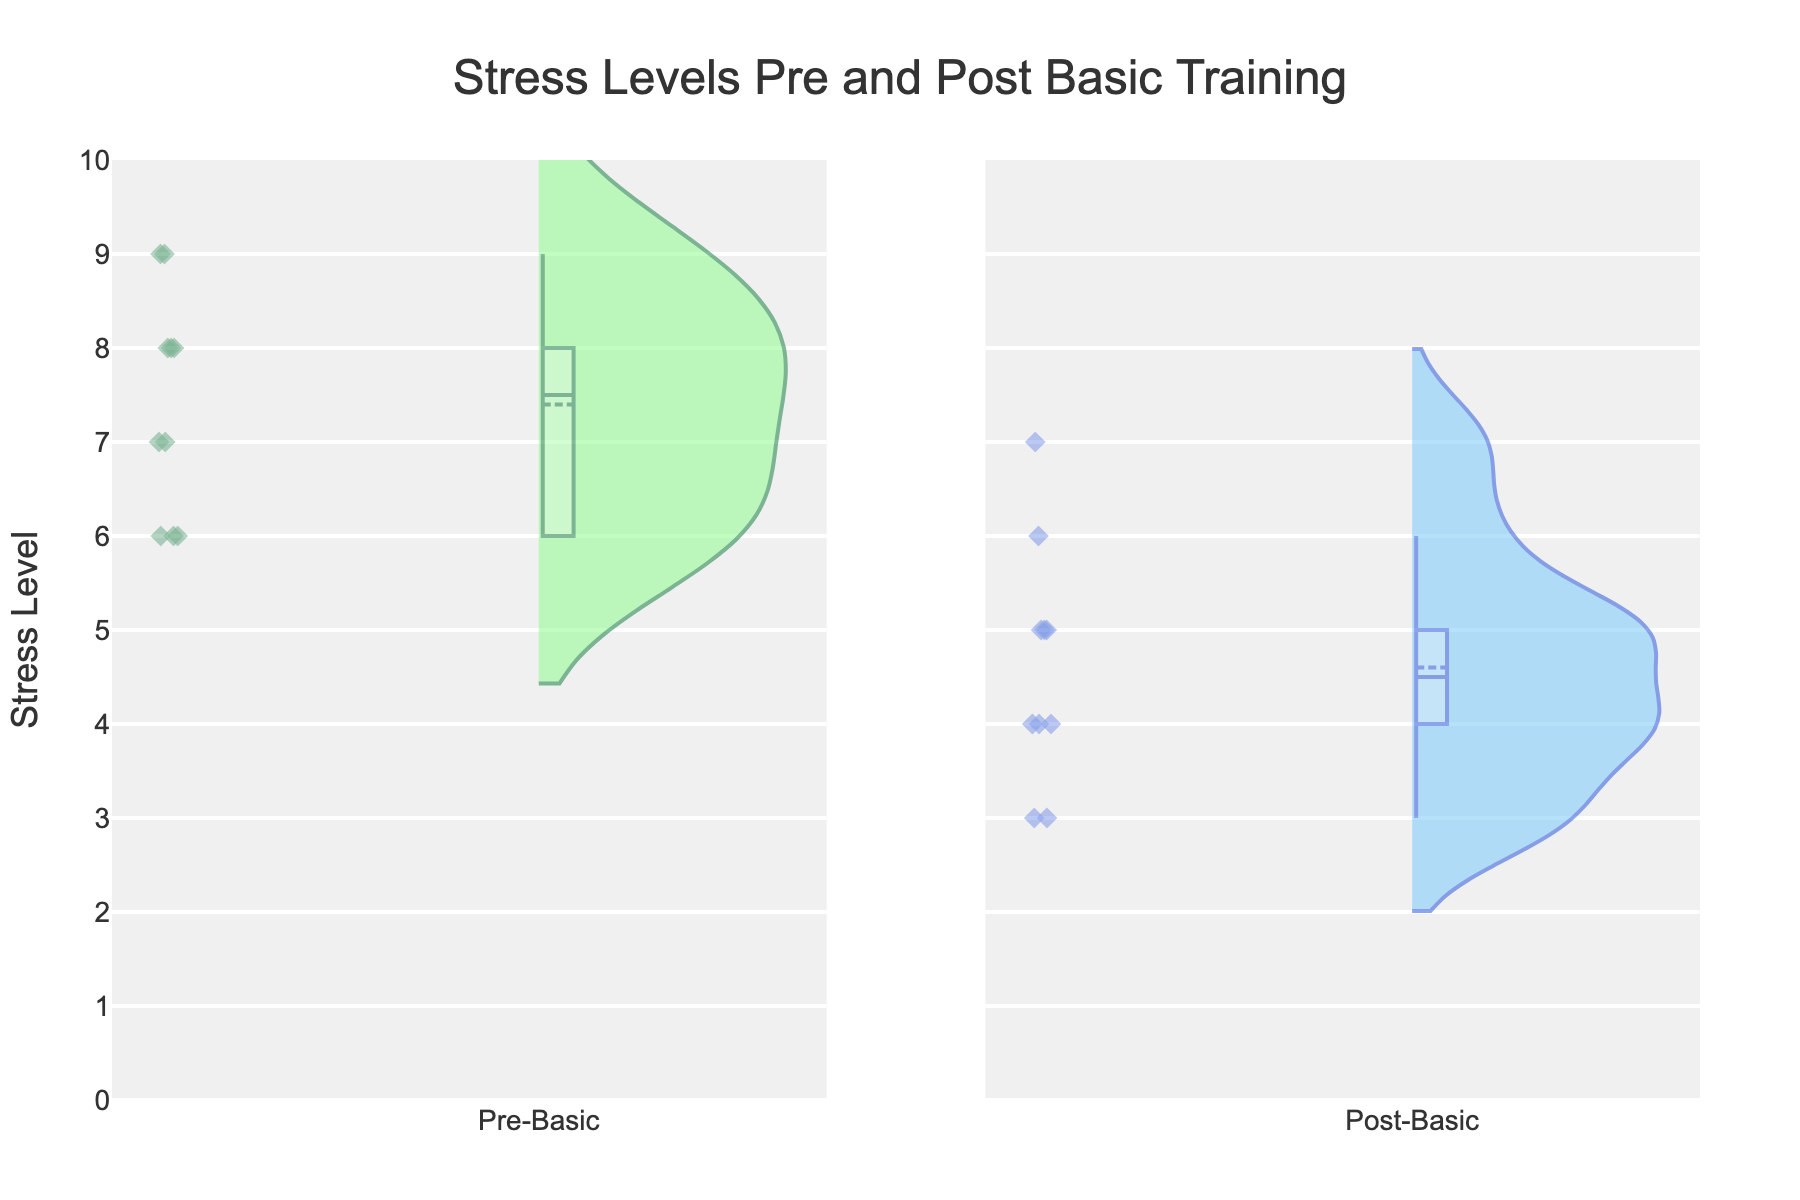What is the title of the plot? The title is usually located at the top of the figure. In this case, it reads "Stress Levels Pre and Post Basic Training."
Answer: Stress Levels Pre and Post Basic Training What does the y-axis represent? The y-axis label is a clear indicator. It reads "Stress Level," which suggests that the y-axis represents the variation in stress levels.
Answer: Stress Level What is the maximum stress level observed in both the pre and post-basic training phases? By looking at the height of the violins along the y-axis, the maximum stress level observed is 9 for the pre-basic phase and 7 for the post-basic phase.
Answer: 9 (Pre-Basic), 7 (Post-Basic) Is the average stress level higher in the pre-basic or post-basic training phase? The mean line (a white horizontal line) within the violins indicates the average value. The mean line in the pre-basic violin is located higher than in the post-basic violin.
Answer: Pre-Basic What is the interquartile range (IQR) for stress levels in the pre-basic training phase? The IQR extends from the first quartile (bottom of the box) to the third quartile (top of the box) within the box plot inside the violin. For pre-basic, the box extends approximately from 6 to 8.5. So, the IQR is 8.5 - 6 = 2.5.
Answer: 2.5 How do the distributions of stress levels compare between the pre-basic and post-basic training phases? The width of the violin plots indicates the distribution. The pre-basic violin is wider towards higher stress values, showing higher frequency, whereas the post-basic violin is wider at lower stress values, indicating a general decrease in stress levels.
Answer: Pre-Basic shows higher stress, Post-Basic shows lower stress Which phase shows more variability in stress levels? Variability can be judged by the spread and width of the violin plots. The pre-basic phase has a wider spread and greater distribution along the y-axis compared to the post-basic phase.
Answer: Pre-Basic How many participants reported a stress level of 9 in the pre-basic phase? The individual data points are represented as markers inside the violin plots. There are two markers at the stress level 9 in the pre-basic phase, indicating two participants.
Answer: 2 What is the range of observed stress levels in the post-basic phase? The range can be observed from the topmost to the bottommost points in the violin plot. For the post-basic phase, it ranges from 3 to 7.
Answer: 3 to 7 How do the median stress levels compare between the two phases? The median is indicated by the central line inside the box. The median stress level for the pre-basic phase is higher than for the post-basic phase.
Answer: Higher in Pre-Basic 